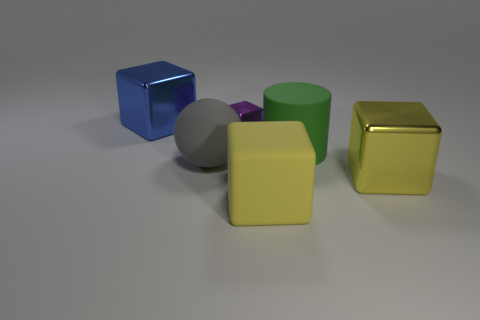What number of cyan things are tiny rubber blocks or small blocks?
Make the answer very short. 0. What is the color of the cylinder?
Offer a very short reply. Green. What is the size of the green thing that is made of the same material as the gray ball?
Offer a terse response. Large. How many tiny purple metallic objects are the same shape as the yellow shiny object?
Provide a short and direct response. 1. Are there any other things that have the same size as the gray ball?
Provide a short and direct response. Yes. What is the size of the yellow block in front of the big shiny cube in front of the large gray matte object?
Offer a very short reply. Large. What material is the ball that is the same size as the rubber cylinder?
Provide a short and direct response. Rubber. Is there a small thing that has the same material as the blue cube?
Give a very brief answer. Yes. What is the color of the large metal object that is to the right of the blue object behind the big shiny cube right of the big sphere?
Your response must be concise. Yellow. Is the color of the big shiny object right of the large blue metallic object the same as the big thing that is on the left side of the big gray matte object?
Provide a succinct answer. No. 